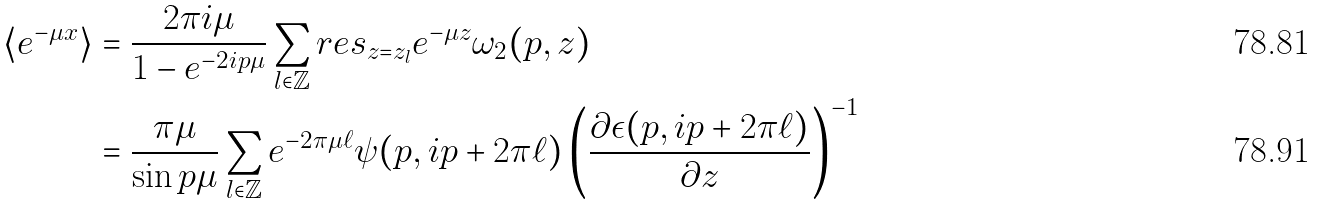<formula> <loc_0><loc_0><loc_500><loc_500>\langle e ^ { - \mu x } \rangle & = \frac { 2 \pi i \mu } { 1 - e ^ { - 2 i p \mu } } \sum _ { l \in \mathbb { Z } } r e s _ { z = z _ { l } } e ^ { - \mu z } \omega _ { 2 } ( p , z ) \\ & = \frac { \pi \mu } { \sin p \mu } \sum _ { l \in \mathbb { Z } } { e ^ { - 2 \pi \mu \ell } \psi ( p , i p + 2 \pi \ell ) } \left ( \frac { \partial \epsilon ( p , i p + 2 \pi \ell ) } { \partial z } \right ) ^ { - 1 }</formula> 